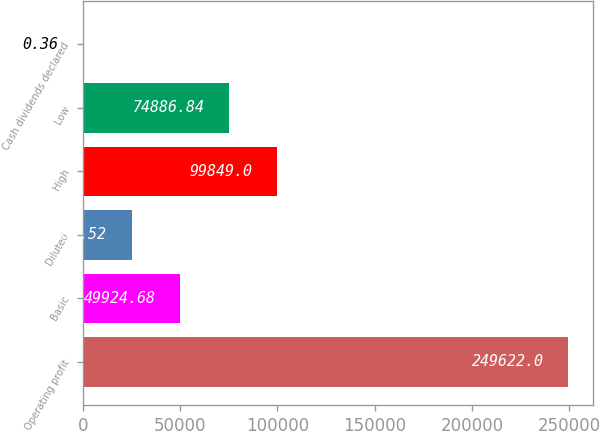Convert chart. <chart><loc_0><loc_0><loc_500><loc_500><bar_chart><fcel>Operating profit<fcel>Basic<fcel>Diluted<fcel>High<fcel>Low<fcel>Cash dividends declared<nl><fcel>249622<fcel>49924.7<fcel>24962.5<fcel>99849<fcel>74886.8<fcel>0.36<nl></chart> 